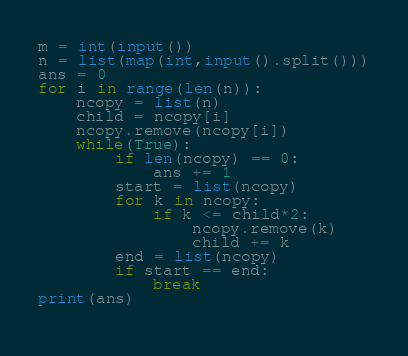<code> <loc_0><loc_0><loc_500><loc_500><_Python_>m = int(input())
n = list(map(int,input().split()))
ans = 0
for i in range(len(n)):
    ncopy = list(n)
    child = ncopy[i]
    ncopy.remove(ncopy[i])
    while(True):
        if len(ncopy) == 0:
            ans += 1    
        start = list(ncopy)
        for k in ncopy:
            if k <= child*2:
                ncopy.remove(k)
                child += k
        end = list(ncopy)
        if start == end:
            break
print(ans)
        </code> 